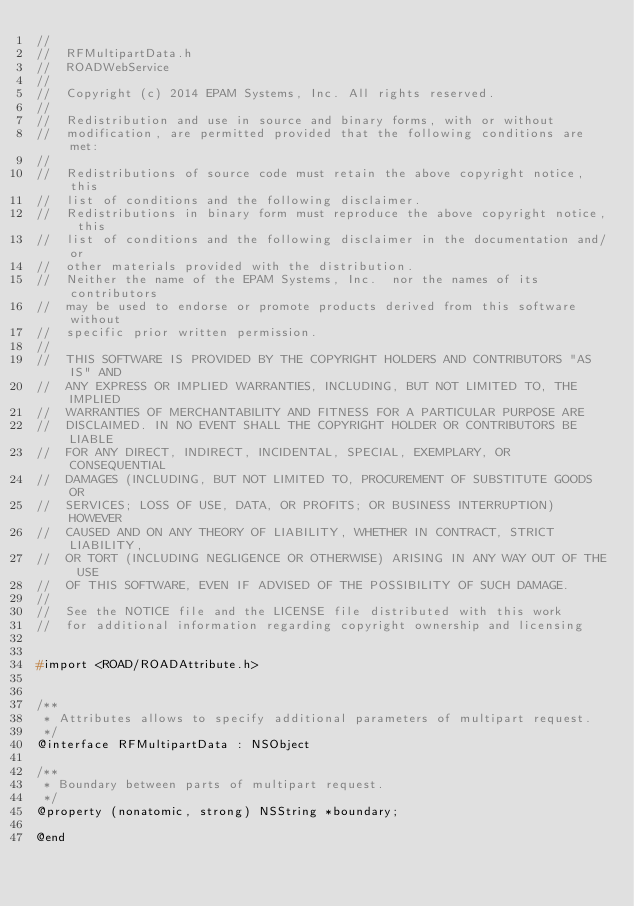<code> <loc_0><loc_0><loc_500><loc_500><_C_>//
//  RFMultipartData.h
//  ROADWebService
//
//  Copyright (c) 2014 EPAM Systems, Inc. All rights reserved.
//
//  Redistribution and use in source and binary forms, with or without
//  modification, are permitted provided that the following conditions are met:
//
//  Redistributions of source code must retain the above copyright notice, this
//  list of conditions and the following disclaimer.
//  Redistributions in binary form must reproduce the above copyright notice, this
//  list of conditions and the following disclaimer in the documentation and/or
//  other materials provided with the distribution.
//  Neither the name of the EPAM Systems, Inc.  nor the names of its contributors
//  may be used to endorse or promote products derived from this software without
//  specific prior written permission.
//
//  THIS SOFTWARE IS PROVIDED BY THE COPYRIGHT HOLDERS AND CONTRIBUTORS "AS IS" AND
//  ANY EXPRESS OR IMPLIED WARRANTIES, INCLUDING, BUT NOT LIMITED TO, THE IMPLIED
//  WARRANTIES OF MERCHANTABILITY AND FITNESS FOR A PARTICULAR PURPOSE ARE
//  DISCLAIMED. IN NO EVENT SHALL THE COPYRIGHT HOLDER OR CONTRIBUTORS BE LIABLE
//  FOR ANY DIRECT, INDIRECT, INCIDENTAL, SPECIAL, EXEMPLARY, OR CONSEQUENTIAL
//  DAMAGES (INCLUDING, BUT NOT LIMITED TO, PROCUREMENT OF SUBSTITUTE GOODS OR
//  SERVICES; LOSS OF USE, DATA, OR PROFITS; OR BUSINESS INTERRUPTION) HOWEVER
//  CAUSED AND ON ANY THEORY OF LIABILITY, WHETHER IN CONTRACT, STRICT LIABILITY,
//  OR TORT (INCLUDING NEGLIGENCE OR OTHERWISE) ARISING IN ANY WAY OUT OF THE USE
//  OF THIS SOFTWARE, EVEN IF ADVISED OF THE POSSIBILITY OF SUCH DAMAGE.
//
//  See the NOTICE file and the LICENSE file distributed with this work
//  for additional information regarding copyright ownership and licensing


#import <ROAD/ROADAttribute.h>


/**
 * Attributes allows to specify additional parameters of multipart request.
 */
@interface RFMultipartData : NSObject

/**
 * Boundary between parts of multipart request.
 */
@property (nonatomic, strong) NSString *boundary;

@end
</code> 